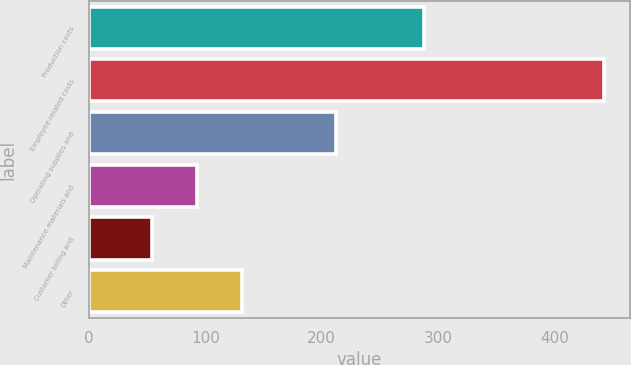Convert chart to OTSL. <chart><loc_0><loc_0><loc_500><loc_500><bar_chart><fcel>Production costs<fcel>Employee-related costs<fcel>Operating supplies and<fcel>Maintenance materials and<fcel>Customer billing and<fcel>Other<nl><fcel>288<fcel>443<fcel>212<fcel>92.9<fcel>54<fcel>131.8<nl></chart> 